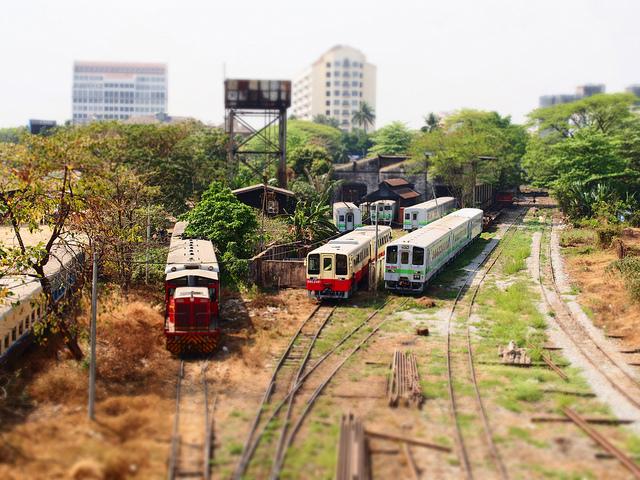Is this train passing through a city?
Be succinct. No. Are there buildings in the photo?
Write a very short answer. Yes. How many sets of train tracks can you see?
Short answer required. 5. Are all the trains heading in the same direction?
Keep it brief. Yes. 